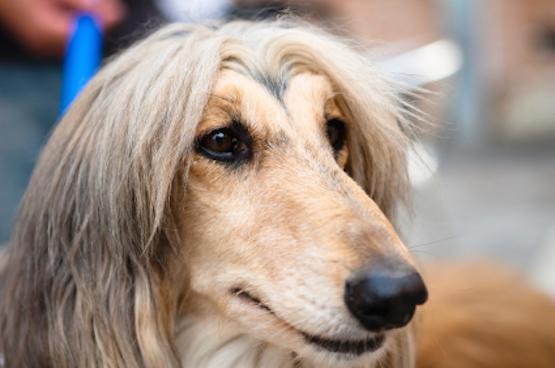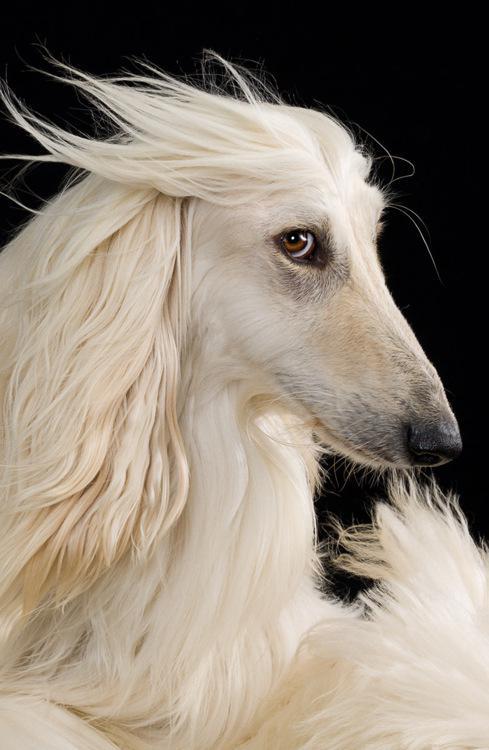The first image is the image on the left, the second image is the image on the right. Examine the images to the left and right. Is the description "One image shows a hound with windswept hair on its head." accurate? Answer yes or no. Yes. 